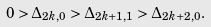Convert formula to latex. <formula><loc_0><loc_0><loc_500><loc_500>0 > \Delta _ { 2 k , 0 } > \Delta _ { 2 k + 1 , 1 } > \Delta _ { 2 k + 2 , 0 } .</formula> 